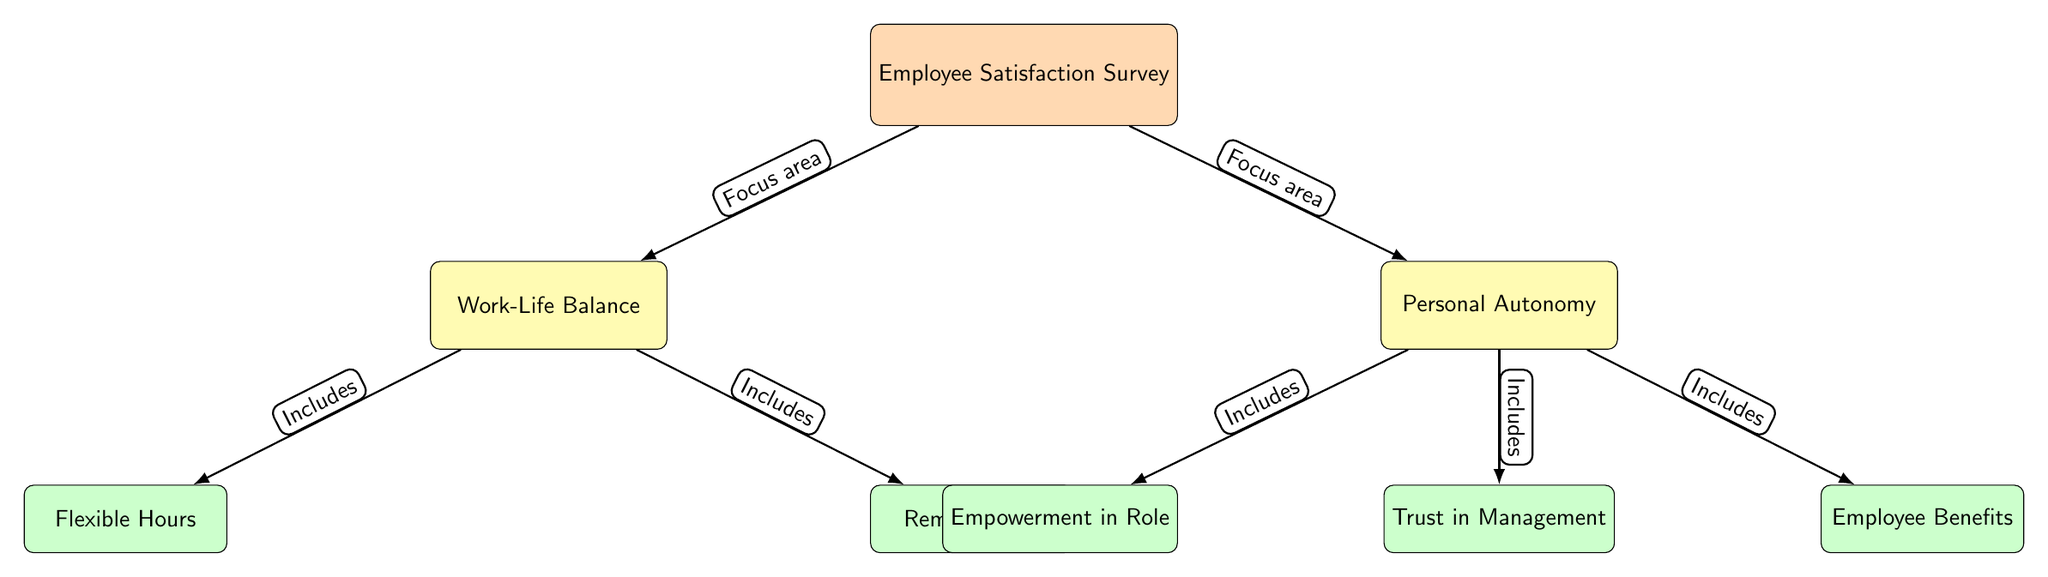What is the main focus of the diagram? The main node in the diagram is labeled "Employee Satisfaction Survey," indicating that this is the central topic of the diagram.
Answer: Employee Satisfaction Survey How many focus areas are identified in the diagram? The diagram shows two focus areas branching from the main node: Work-Life Balance and Personal Autonomy. Thus, the count of focus areas is two.
Answer: 2 Which sub-category is related to Work-Life Balance? The Work-Life Balance focus area includes two sub-categories, one of which is labeled "Flexible Hours."
Answer: Flexible Hours What relationship does "Trust in Management" have in the diagram? The node labeled "Trust in Management" is a sub-category that falls under the focus area of Personal Autonomy, showing it as an important element of employee autonomy.
Answer: Includes How many sub-categories are connected to Personal Autonomy? The diagram indicates three sub-categories branching from Personal Autonomy, which are Empowerment in Role, Trust in Management, and Employee Benefits. Therefore, the total is three.
Answer: 3 What is the relationship between "Work-Life Balance" and "Flexible Hours"? The diagram shows that "Flexible Hours" is a sub-category that is included under "Work-Life Balance," indicating that it is a component contributing to employee satisfaction in that area.
Answer: Includes How many edges are there connecting the main survey node to the focus areas? There are two edges connecting the main node (Employee Satisfaction Survey) to its focus areas (Work-Life Balance and Personal Autonomy), thus the total count of edges is two.
Answer: 2 How is "Remote Work" categorized in the diagram? The node "Remote Work" is a sub-category under the focus area of Work-Life Balance, indicating it is part of ensuring balance for employees.
Answer: Includes Which focus area connects the most sub-categories? The focus area "Personal Autonomy" connects to three sub-categories: Empowerment in Role, Trust in Management, and Employee Benefits, making it the area with the most connections.
Answer: Personal Autonomy 